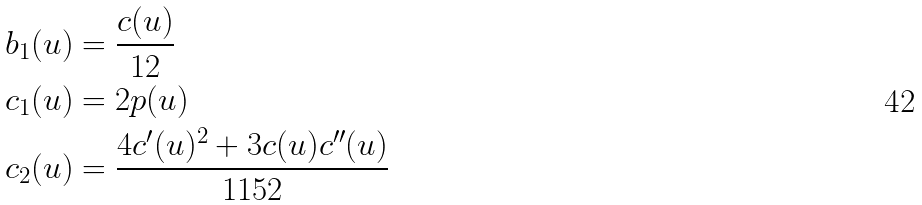<formula> <loc_0><loc_0><loc_500><loc_500>& b _ { 1 } ( u ) = \frac { c ( u ) } { 1 2 } \\ & c _ { 1 } ( u ) = 2 p ( u ) \\ & c _ { 2 } ( u ) = \frac { 4 c ^ { \prime } ( u ) ^ { 2 } + 3 c ( u ) c ^ { \prime \prime } ( u ) } { 1 1 5 2 }</formula> 